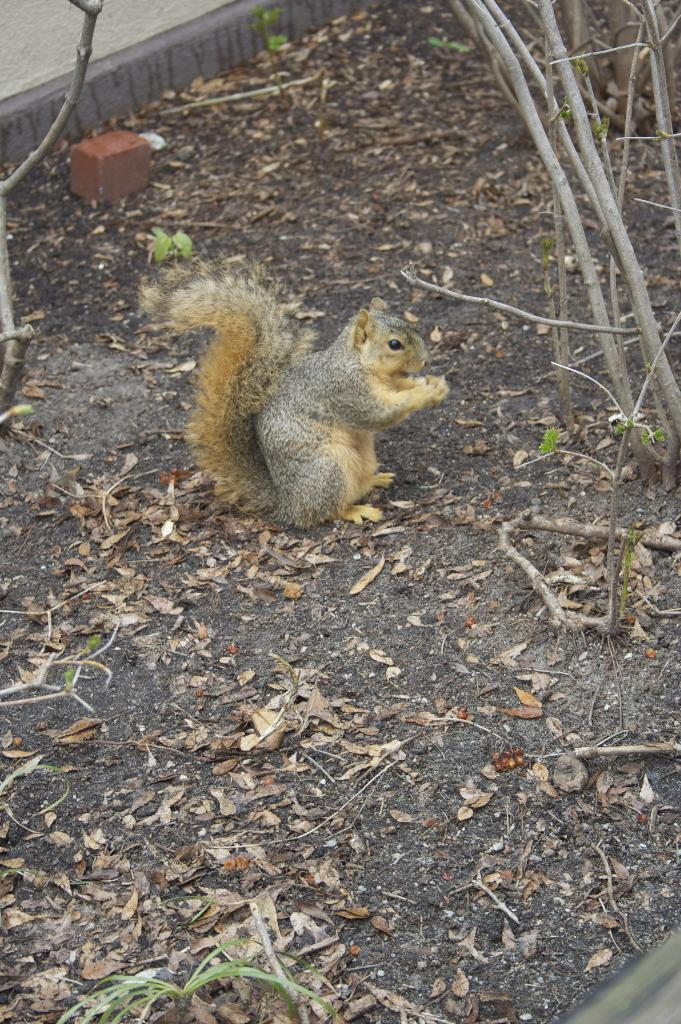What is the main subject in the center of the image? There is a squirrel in the center of the image. What type of vegetation can be seen around the area? Dry leaves and stems are present around the area. What type of payment method is accepted by the squirrel in the image? There is no payment method mentioned or implied in the image, as it features a squirrel and vegetation. 